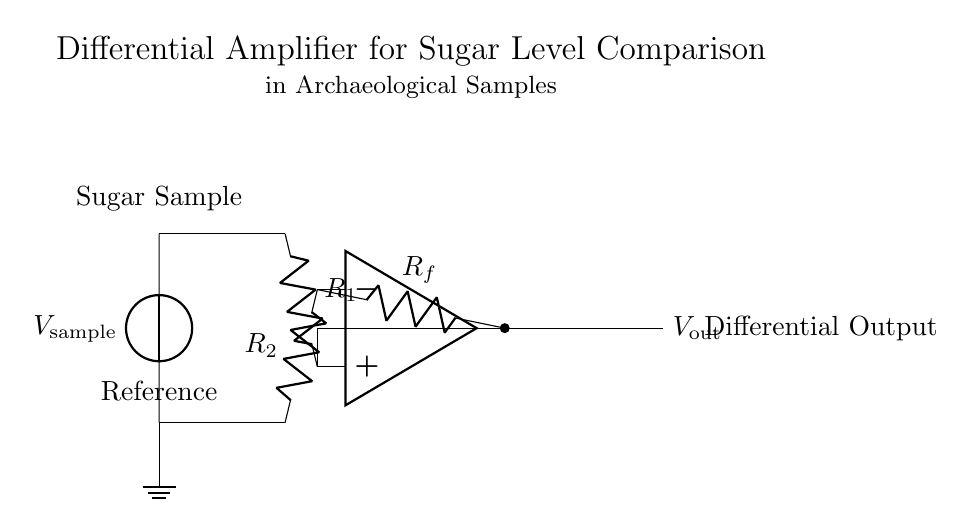What type of amplifier is presented in this circuit? The circuit shows a differential amplifier, which is characterized by its comparison of two input voltages to produce a corresponding output voltage.
Answer: Differential amplifier What are the labeled components at the left side of the circuit? The left side of the circuit is labeled with "Sugar Sample" for the upper voltage source and "Reference" for the lower voltage source, indicating the two different input voltages being compared.
Answer: Sugar Sample and Reference What role do resistors play in this circuit? The resistors in this differential amplifier circuit serve to set the gain and balance the inputs, allowing for accurate voltage comparison between the sugar sample and reference voltage.
Answer: Set gain and balance inputs What is the output of this amplifier circuit labeled as? The output of the amplifier is labeled as "Differential Output," which indicates the result of the comparison between the two input voltages, representing the difference between the sugar sample and reference.
Answer: Differential Output How many resistors are used in the amplifier circuit? There are three resistors indicated in the circuit diagram: R1, R2, and Rf, which are essential for controlling the input and feedback of the amplifier.
Answer: Three resistors What is the significance of the connections to the op-amp terminals? The connections to the op-amp terminals denote the inverting and non-inverting inputs of the differential amplifier, which are crucial for determining how the input signals will affect the output voltage.
Answer: Inverting and non-inverting inputs What is the purpose of the ground in this circuit? The ground in the circuit provides a common reference point for voltage measurements and establishes the zero-volt level for the circuit, ensuring stability and proper functioning of the amplifier.
Answer: Common reference for voltage measurements 